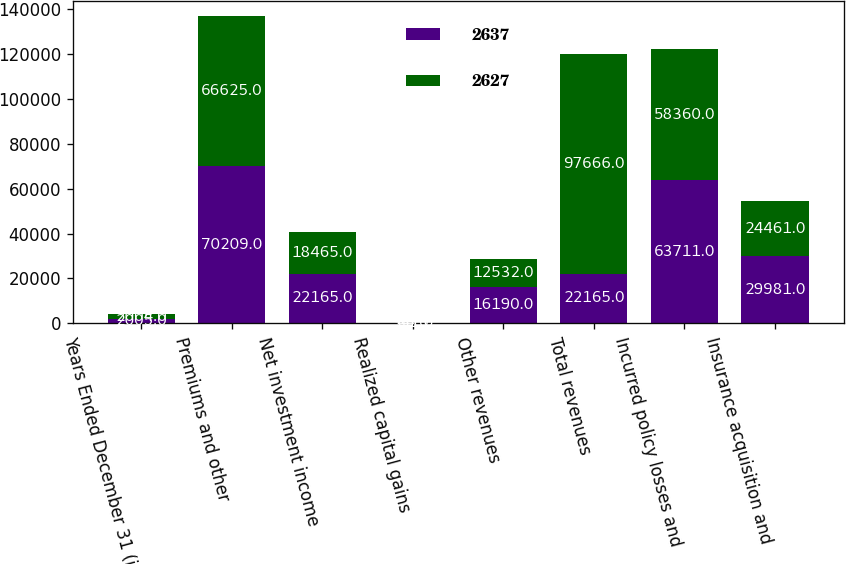Convert chart. <chart><loc_0><loc_0><loc_500><loc_500><stacked_bar_chart><ecel><fcel>Years Ended December 31 (in<fcel>Premiums and other<fcel>Net investment income<fcel>Realized capital gains<fcel>Other revenues<fcel>Total revenues<fcel>Incurred policy losses and<fcel>Insurance acquisition and<nl><fcel>2637<fcel>2005<fcel>70209<fcel>22165<fcel>341<fcel>16190<fcel>22165<fcel>63711<fcel>29981<nl><fcel>2627<fcel>2004<fcel>66625<fcel>18465<fcel>44<fcel>12532<fcel>97666<fcel>58360<fcel>24461<nl></chart> 